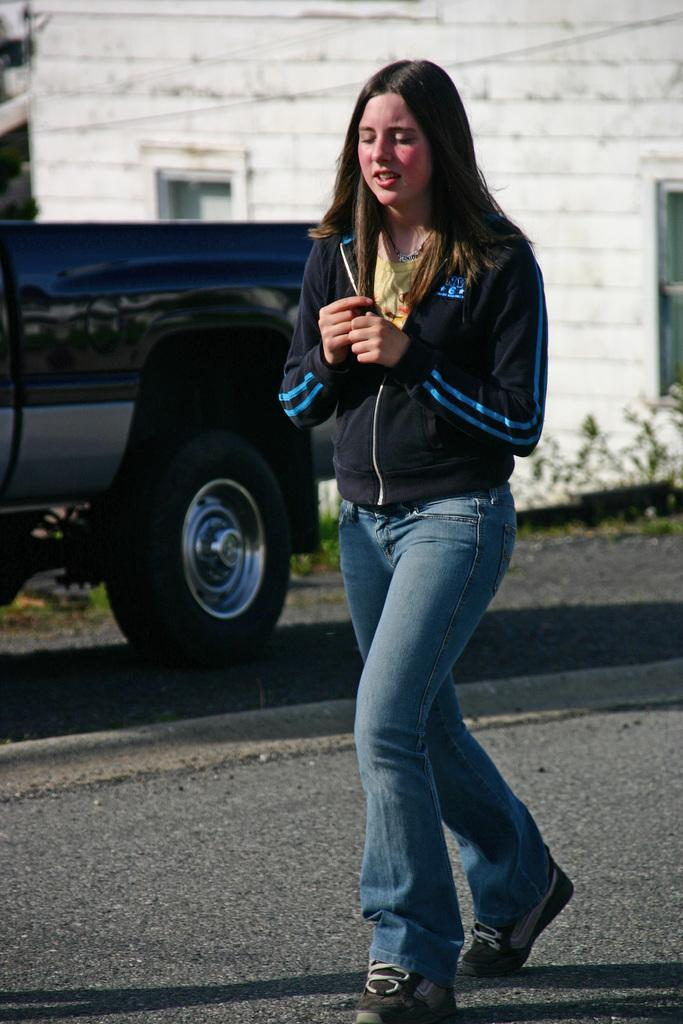Who is present in the image? There is a person in the image. What is the person wearing? The person is wearing a black jacket and blue pants. What can be seen in the background of the image? There is a vehicle and a white building in the background of the image. What force is being exerted by the person's mind in the image? There is no mention of any force or mind-related activity in the image; it simply shows a person wearing a black jacket and blue pants, with a vehicle and a white building in the background. 